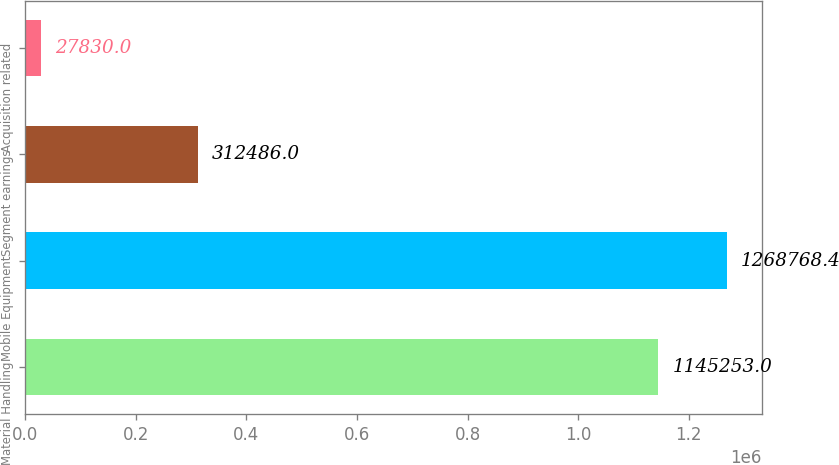Convert chart. <chart><loc_0><loc_0><loc_500><loc_500><bar_chart><fcel>Material Handling<fcel>Mobile Equipment<fcel>Segment earnings<fcel>Acquisition related<nl><fcel>1.14525e+06<fcel>1.26877e+06<fcel>312486<fcel>27830<nl></chart> 